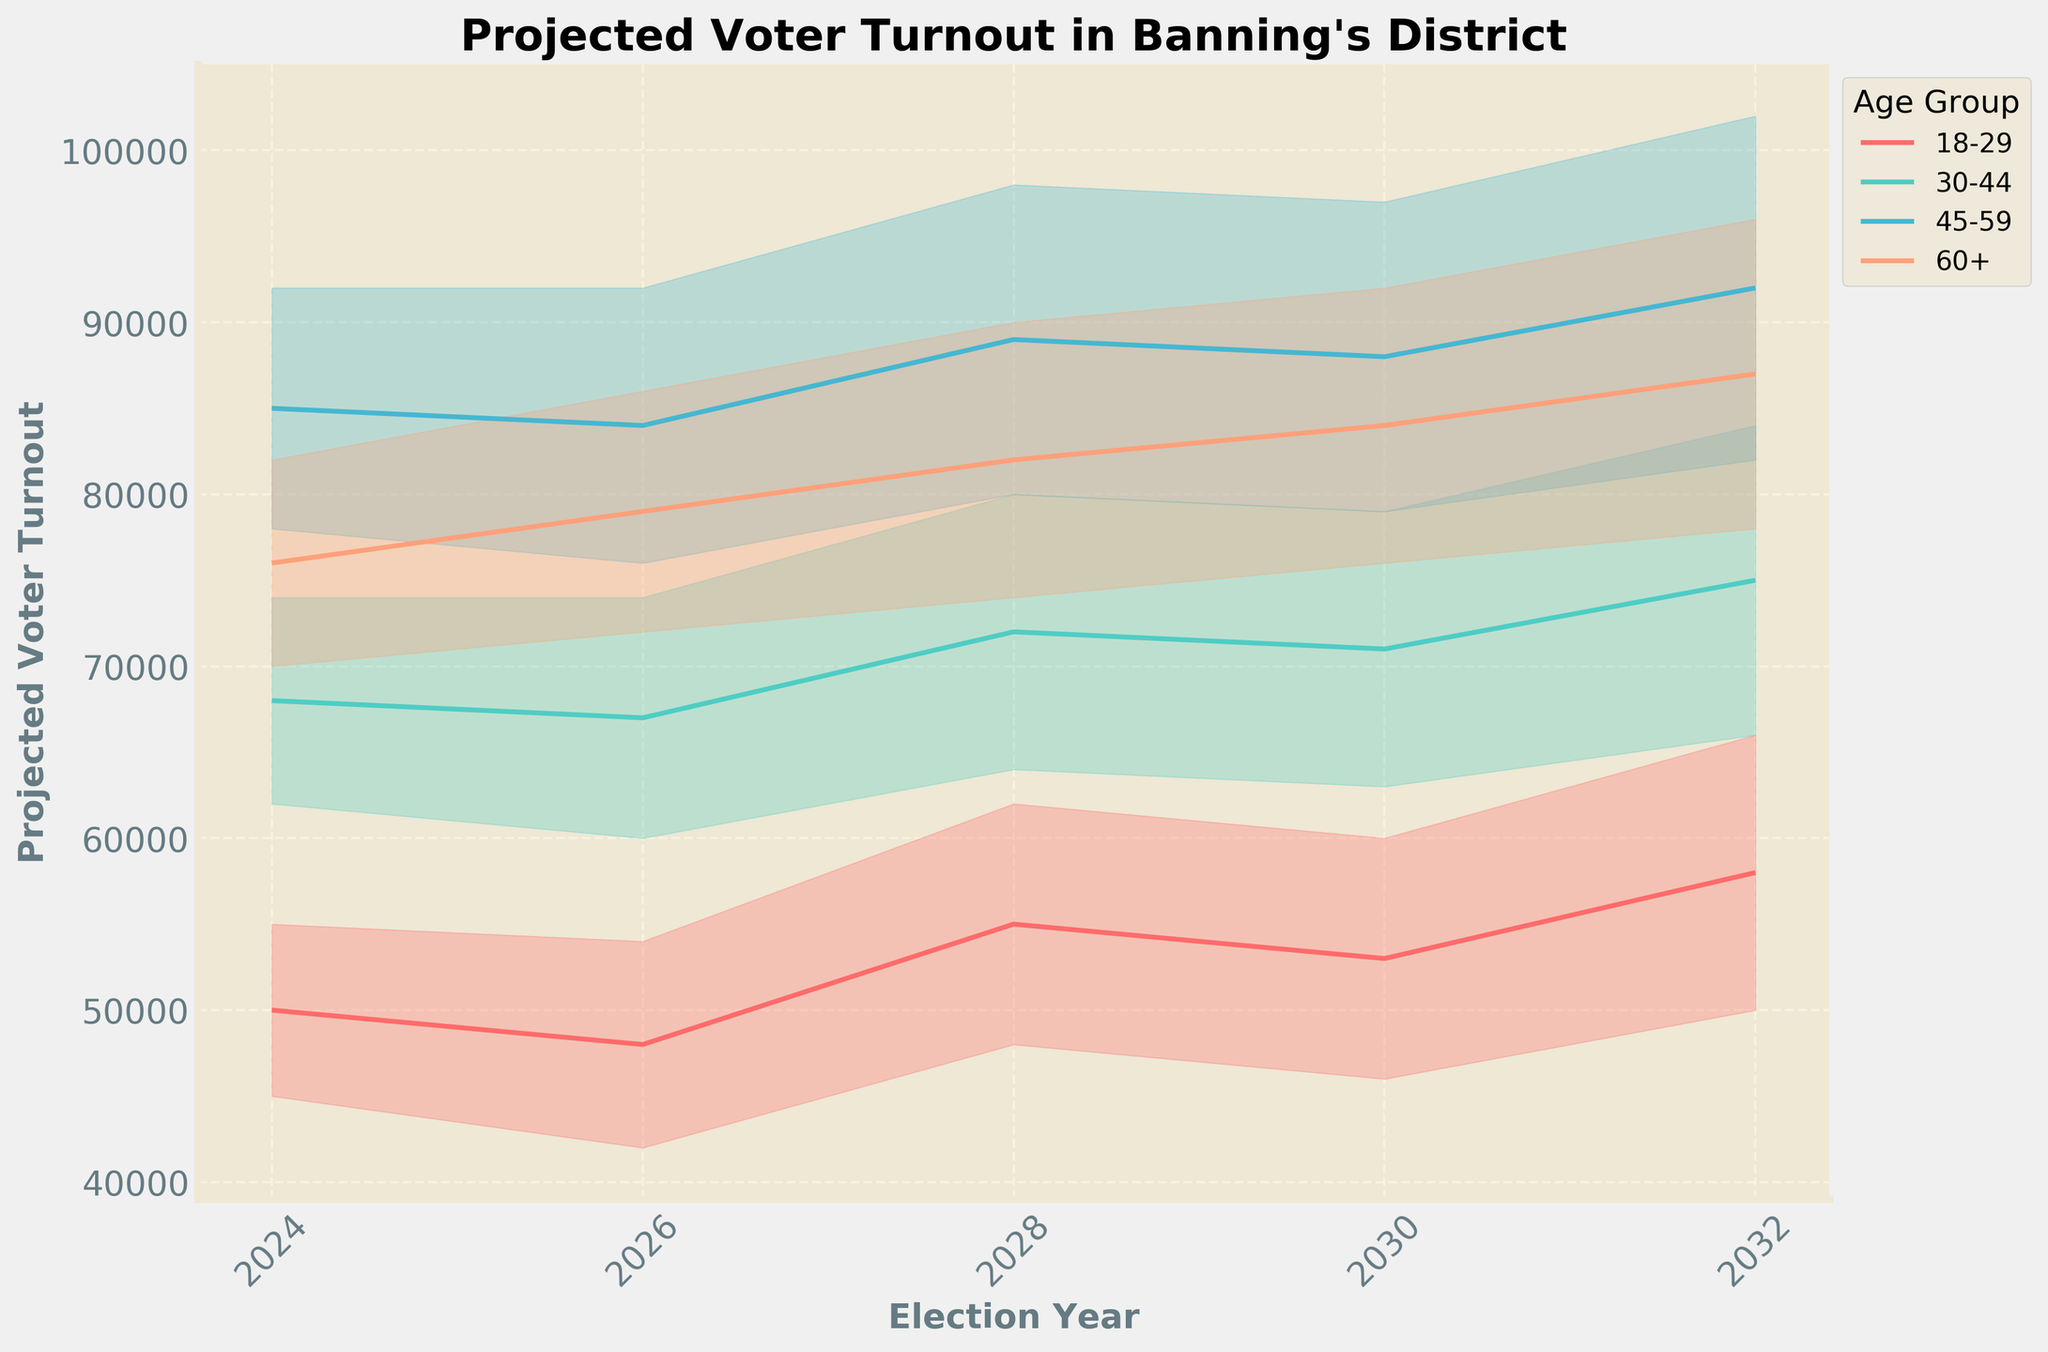Which age group has the highest projected median voter turnout in 2024? In 2024, the 45-59 age group has a higher median voter turnout than the other age groups, reaching 85,000 compared to 50,000 for 18-29, 68,000 for 30-44, and 76,000 for 60+.
Answer: 45-59 Does the median voter turnout for the 18-29 age group increase or decrease from 2026 to 2028? The median projected voter turnout for the 18-29 age group increases from 48,000 in 2026 to 55,000 in 2028.
Answer: Increase Which age group shows the smallest spread (difference between upper and lower bounds) in projected voter turnout in 2030? In 2030, the 60+ age group shows the smallest spread between upper and lower bounds with values 92,000 - 76,000 = 16,000, compared to 14,000 for 18-29, 16,000 for 30-44, and 18,000 for 45-59.
Answer: 60+ Is the trend in voter turnout for all age groups increasing towards 2032? Across all age groups, the trend for the median projected voter turnout increases. For 18-29, the median rises from 50,000 in 2024 to 58,000 in 2032. For 30-44, it rises from 68,000 to 75,000, 45-59 rises from 85,000 to 92,000, and 60+ increases from 76,000 to 87,000.
Answer: Yes What is the median projected voter turnout for the 45-59 age group in 2032? In 2032, the median projected voter turnout for the 45-59 age group is 92,000.
Answer: 92,000 How does the projected median voter turnout for the 30-44 age group in 2024 compare with its value in 2032? In 2024, the median voter turnout for the 30-44 age group is 68,000, and it increases to 75,000 by 2032.
Answer: 7,000 more in 2032 What is the difference between the upper bound projections for the 30-44 and 60+ age groups in 2028? In 2028, the upper bound projections are 80,000 for 30-44 and 90,000 for 60+. The difference is 90,000 - 80,000 = 10,000.
Answer: 10,000 Considering the projections for 2024, what is the range of voter turnout for the 18-29 age group? For 2024, the range of projected voter turnout for the 18-29 age group is between 45,000 and 55,000. The range is 55,000 - 45,000 = 10,000.
Answer: 10,000 During which election cycle do the upper bound projections for the 18-29 and 60+ age groups first equal or exceed 90,000? The upper bound projections for the 18-29 age group exceed 90,000 in 2032 (66,000) and for the 60+ age group in 2028.
Answer: 2028 for 60+ Which age group's projected voter turnout increases the most from 2026 to 2032 in terms of median values? From 2026 to 2032, the projected median voter turnout for the 18-29 age group increases by 10,000 (from 48,000 to 58,000), for 30-44 by 8,000 (from 67,000 to 75,000), for 45-59 by 8,000 (from 84,000 to 92,000), and for 60+ by 8,000 (from 79,000 to 87,000). The 18-29 age group shows the largest increment.
Answer: 18-29 